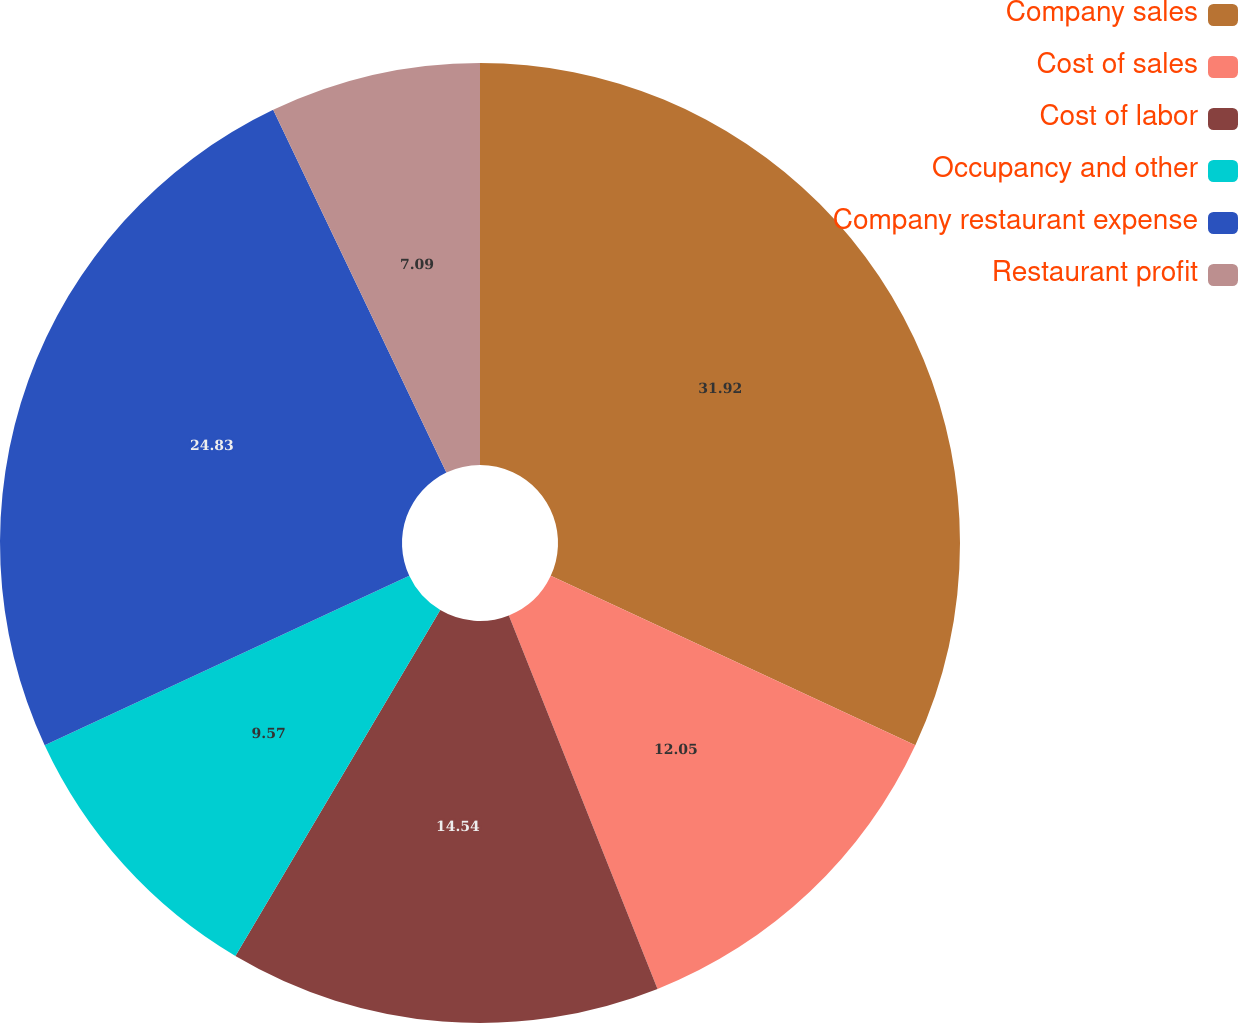Convert chart. <chart><loc_0><loc_0><loc_500><loc_500><pie_chart><fcel>Company sales<fcel>Cost of sales<fcel>Cost of labor<fcel>Occupancy and other<fcel>Company restaurant expense<fcel>Restaurant profit<nl><fcel>31.92%<fcel>12.05%<fcel>14.54%<fcel>9.57%<fcel>24.83%<fcel>7.09%<nl></chart> 